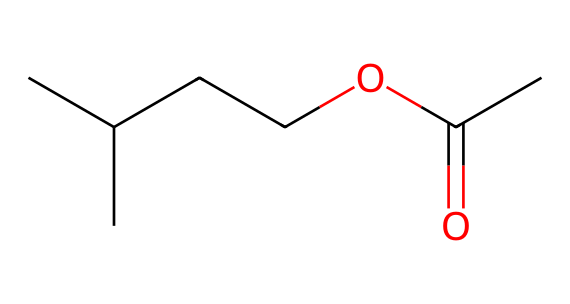What is the total number of carbon atoms in this compound? By analyzing the SMILES representation, we can see that there are four carbon 'C' atoms in the branched chain and one carbon in the ester functional group (C=O), plus one from the carbonyl oxygen moiety, resulting in a total of six carbon atoms overall.
Answer: six How many oxygen atoms does this molecule contain? The SMILES representation includes two instances of 'O': one in the ether part (OC) and the other in the carboxylic acid ester part (=O), which confirms that there are two oxygen atoms present.
Answer: two What type of functional group is indicated by the text 'OC(C)=O'? In the SMILES, 'C(C)=O' signifies a carbonyl (C=O) linked to an oxygen (O) which indicates an ester functional group, as it is formed from an alcohol and a carboxylic acid.
Answer: ester What is the empirical formula for this compound? To derive the empirical formula, we count the atoms: there are six carbons, twelve hydrogens, and two oxygens, leading us to the empirical formula C6H12O2 based on the whole structure.
Answer: C6H12O2 What kind of aromatic compounds can be derived from this structure? The presence of the ester functional group allows for the formation of peachy or fruity aromatic compounds when subjected to fermentation or heating, which are typical in flavor compounds in beer.
Answer: fruity How does the branching of the carbon chain affect the aroma profile? The branching in the carbon chain can create a varied and complex aroma profile by influencing the volatility of compounds, leading to unique, pleasant scents that enhance the overall beer flavor.
Answer: unique scents 